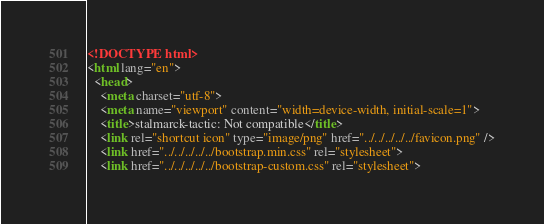<code> <loc_0><loc_0><loc_500><loc_500><_HTML_><!DOCTYPE html>
<html lang="en">
  <head>
    <meta charset="utf-8">
    <meta name="viewport" content="width=device-width, initial-scale=1">
    <title>stalmarck-tactic: Not compatible</title>
    <link rel="shortcut icon" type="image/png" href="../../../../../favicon.png" />
    <link href="../../../../../bootstrap.min.css" rel="stylesheet">
    <link href="../../../../../bootstrap-custom.css" rel="stylesheet"></code> 